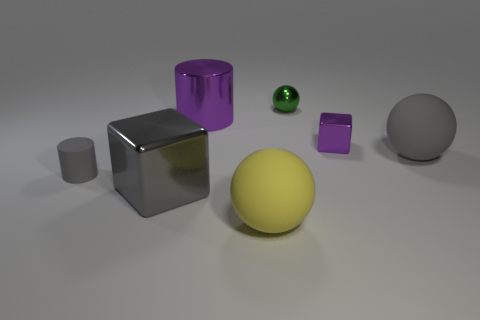Add 2 large blue cylinders. How many objects exist? 9 Subtract all cubes. How many objects are left? 5 Add 5 yellow matte spheres. How many yellow matte spheres are left? 6 Add 5 big yellow balls. How many big yellow balls exist? 6 Subtract 0 green cubes. How many objects are left? 7 Subtract all small gray cylinders. Subtract all blue shiny spheres. How many objects are left? 6 